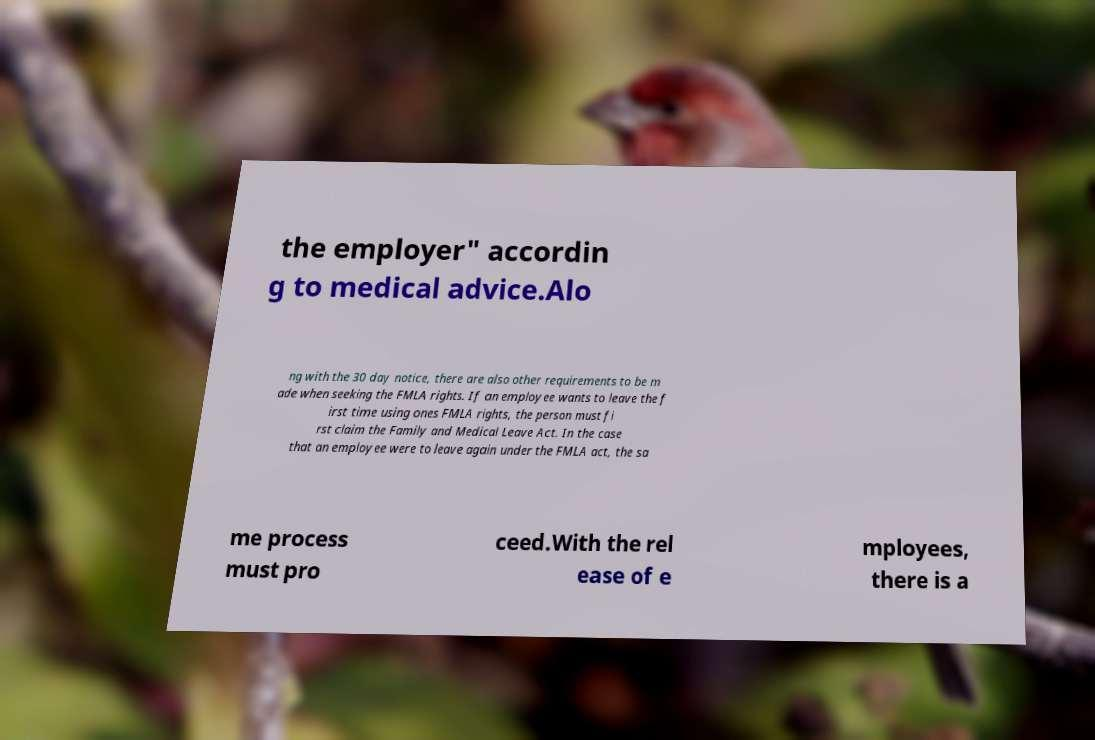What messages or text are displayed in this image? I need them in a readable, typed format. the employer" accordin g to medical advice.Alo ng with the 30 day notice, there are also other requirements to be m ade when seeking the FMLA rights. If an employee wants to leave the f irst time using ones FMLA rights, the person must fi rst claim the Family and Medical Leave Act. In the case that an employee were to leave again under the FMLA act, the sa me process must pro ceed.With the rel ease of e mployees, there is a 